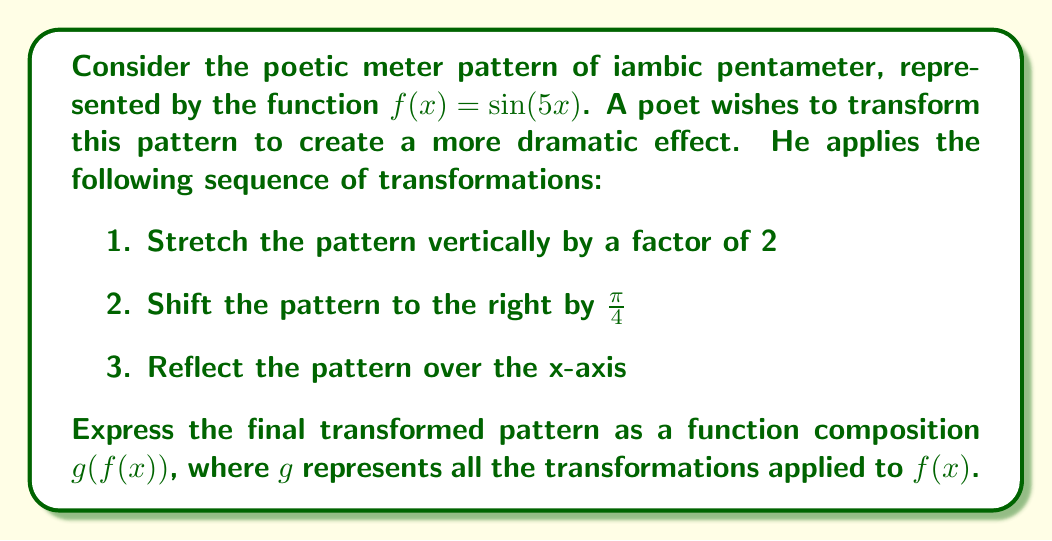Give your solution to this math problem. Let's approach this step-by-step:

1. The original function is $f(x) = \sin(5x)$, representing the iambic pentameter.

2. To stretch the pattern vertically by a factor of 2, we multiply the function by 2:
   $2\sin(5x)$

3. To shift the pattern to the right by $\frac{\pi}{4}$, we subtract $\frac{\pi}{4}$ from the input of the sine function:
   $2\sin(5(x - \frac{\pi}{4}))$

4. To reflect the pattern over the x-axis, we negate the entire function:
   $-2\sin(5(x - \frac{\pi}{4}))$

5. Now, we need to express this as a function composition $g(f(x))$. 
   Let $g(x) = -2\sin(x - \frac{5\pi}{4})$
   
   Then, $g(f(x)) = g(\sin(5x)) = -2\sin(\sin(5x) - \frac{5\pi}{4})$

6. This composition $g(f(x))$ represents all the transformations applied to the original function $f(x)$.
Answer: $g(f(x)) = -2\sin(\sin(5x) - \frac{5\pi}{4})$ 